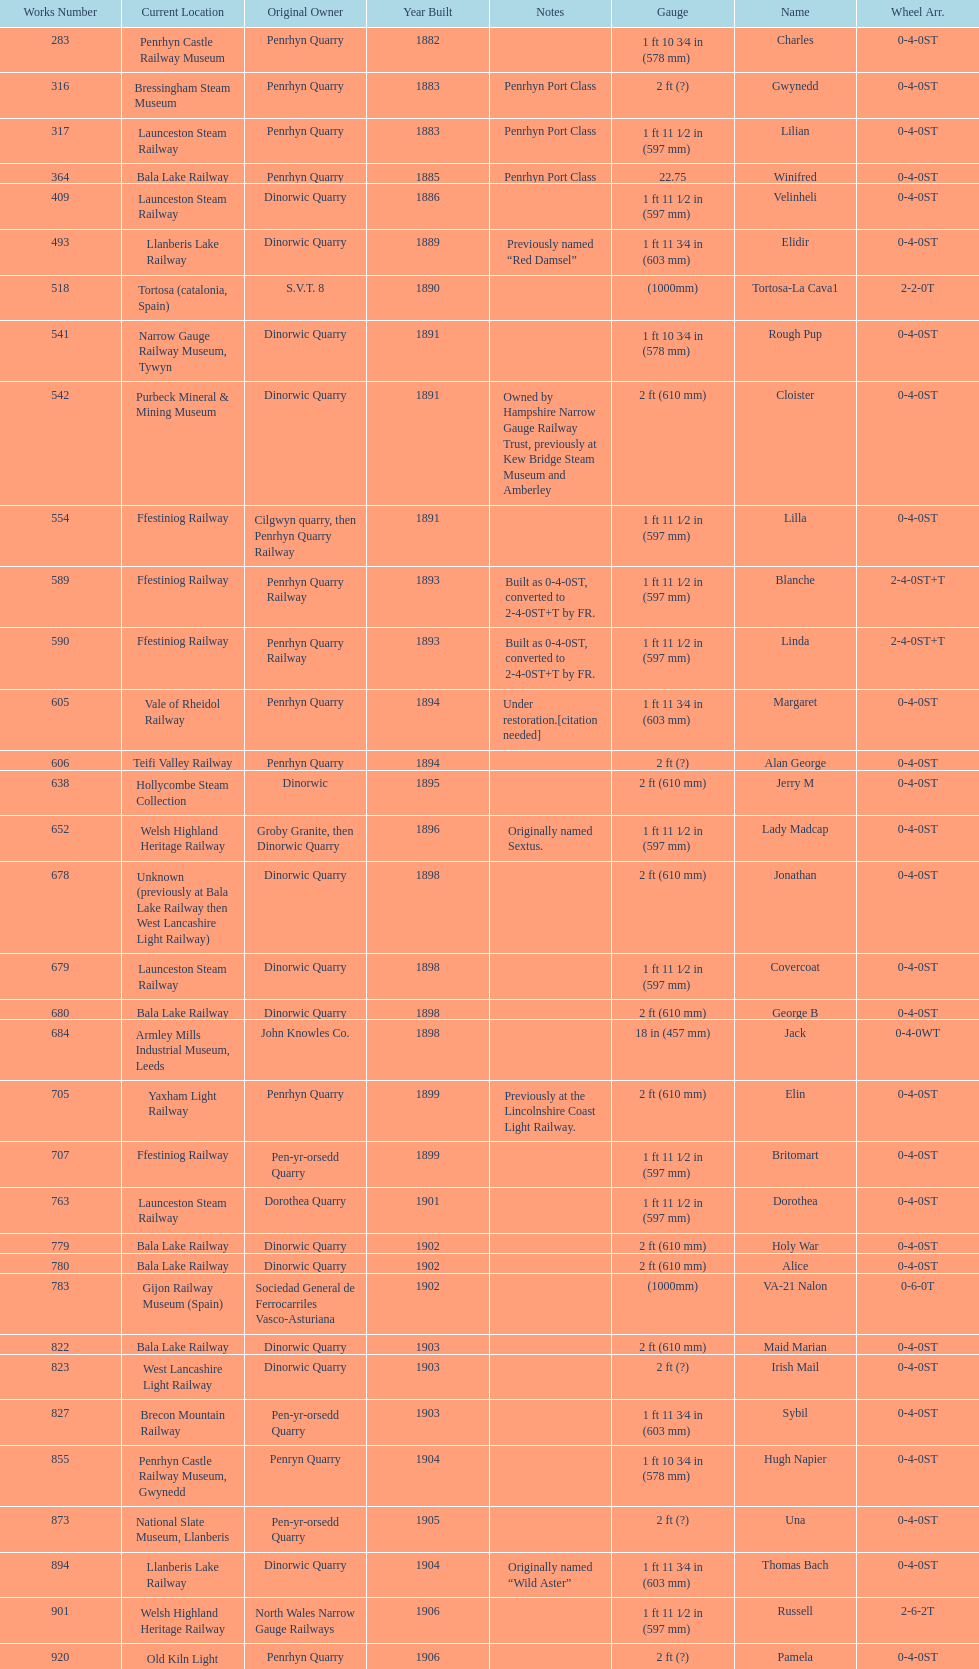Parse the table in full. {'header': ['Works Number', 'Current Location', 'Original Owner', 'Year Built', 'Notes', 'Gauge', 'Name', 'Wheel Arr.'], 'rows': [['283', 'Penrhyn Castle Railway Museum', 'Penrhyn Quarry', '1882', '', '1\xa0ft 10\xa03⁄4\xa0in (578\xa0mm)', 'Charles', '0-4-0ST'], ['316', 'Bressingham Steam Museum', 'Penrhyn Quarry', '1883', 'Penrhyn Port Class', '2\xa0ft (?)', 'Gwynedd', '0-4-0ST'], ['317', 'Launceston Steam Railway', 'Penrhyn Quarry', '1883', 'Penrhyn Port Class', '1\xa0ft 11\xa01⁄2\xa0in (597\xa0mm)', 'Lilian', '0-4-0ST'], ['364', 'Bala Lake Railway', 'Penrhyn Quarry', '1885', 'Penrhyn Port Class', '22.75', 'Winifred', '0-4-0ST'], ['409', 'Launceston Steam Railway', 'Dinorwic Quarry', '1886', '', '1\xa0ft 11\xa01⁄2\xa0in (597\xa0mm)', 'Velinheli', '0-4-0ST'], ['493', 'Llanberis Lake Railway', 'Dinorwic Quarry', '1889', 'Previously named “Red Damsel”', '1\xa0ft 11\xa03⁄4\xa0in (603\xa0mm)', 'Elidir', '0-4-0ST'], ['518', 'Tortosa (catalonia, Spain)', 'S.V.T. 8', '1890', '', '(1000mm)', 'Tortosa-La Cava1', '2-2-0T'], ['541', 'Narrow Gauge Railway Museum, Tywyn', 'Dinorwic Quarry', '1891', '', '1\xa0ft 10\xa03⁄4\xa0in (578\xa0mm)', 'Rough Pup', '0-4-0ST'], ['542', 'Purbeck Mineral & Mining Museum', 'Dinorwic Quarry', '1891', 'Owned by Hampshire Narrow Gauge Railway Trust, previously at Kew Bridge Steam Museum and Amberley', '2\xa0ft (610\xa0mm)', 'Cloister', '0-4-0ST'], ['554', 'Ffestiniog Railway', 'Cilgwyn quarry, then Penrhyn Quarry Railway', '1891', '', '1\xa0ft 11\xa01⁄2\xa0in (597\xa0mm)', 'Lilla', '0-4-0ST'], ['589', 'Ffestiniog Railway', 'Penrhyn Quarry Railway', '1893', 'Built as 0-4-0ST, converted to 2-4-0ST+T by FR.', '1\xa0ft 11\xa01⁄2\xa0in (597\xa0mm)', 'Blanche', '2-4-0ST+T'], ['590', 'Ffestiniog Railway', 'Penrhyn Quarry Railway', '1893', 'Built as 0-4-0ST, converted to 2-4-0ST+T by FR.', '1\xa0ft 11\xa01⁄2\xa0in (597\xa0mm)', 'Linda', '2-4-0ST+T'], ['605', 'Vale of Rheidol Railway', 'Penrhyn Quarry', '1894', 'Under restoration.[citation needed]', '1\xa0ft 11\xa03⁄4\xa0in (603\xa0mm)', 'Margaret', '0-4-0ST'], ['606', 'Teifi Valley Railway', 'Penrhyn Quarry', '1894', '', '2\xa0ft (?)', 'Alan George', '0-4-0ST'], ['638', 'Hollycombe Steam Collection', 'Dinorwic', '1895', '', '2\xa0ft (610\xa0mm)', 'Jerry M', '0-4-0ST'], ['652', 'Welsh Highland Heritage Railway', 'Groby Granite, then Dinorwic Quarry', '1896', 'Originally named Sextus.', '1\xa0ft 11\xa01⁄2\xa0in (597\xa0mm)', 'Lady Madcap', '0-4-0ST'], ['678', 'Unknown (previously at Bala Lake Railway then West Lancashire Light Railway)', 'Dinorwic Quarry', '1898', '', '2\xa0ft (610\xa0mm)', 'Jonathan', '0-4-0ST'], ['679', 'Launceston Steam Railway', 'Dinorwic Quarry', '1898', '', '1\xa0ft 11\xa01⁄2\xa0in (597\xa0mm)', 'Covercoat', '0-4-0ST'], ['680', 'Bala Lake Railway', 'Dinorwic Quarry', '1898', '', '2\xa0ft (610\xa0mm)', 'George B', '0-4-0ST'], ['684', 'Armley Mills Industrial Museum, Leeds', 'John Knowles Co.', '1898', '', '18\xa0in (457\xa0mm)', 'Jack', '0-4-0WT'], ['705', 'Yaxham Light Railway', 'Penrhyn Quarry', '1899', 'Previously at the Lincolnshire Coast Light Railway.', '2\xa0ft (610\xa0mm)', 'Elin', '0-4-0ST'], ['707', 'Ffestiniog Railway', 'Pen-yr-orsedd Quarry', '1899', '', '1\xa0ft 11\xa01⁄2\xa0in (597\xa0mm)', 'Britomart', '0-4-0ST'], ['763', 'Launceston Steam Railway', 'Dorothea Quarry', '1901', '', '1\xa0ft 11\xa01⁄2\xa0in (597\xa0mm)', 'Dorothea', '0-4-0ST'], ['779', 'Bala Lake Railway', 'Dinorwic Quarry', '1902', '', '2\xa0ft (610\xa0mm)', 'Holy War', '0-4-0ST'], ['780', 'Bala Lake Railway', 'Dinorwic Quarry', '1902', '', '2\xa0ft (610\xa0mm)', 'Alice', '0-4-0ST'], ['783', 'Gijon Railway Museum (Spain)', 'Sociedad General de Ferrocarriles Vasco-Asturiana', '1902', '', '(1000mm)', 'VA-21 Nalon', '0-6-0T'], ['822', 'Bala Lake Railway', 'Dinorwic Quarry', '1903', '', '2\xa0ft (610\xa0mm)', 'Maid Marian', '0-4-0ST'], ['823', 'West Lancashire Light Railway', 'Dinorwic Quarry', '1903', '', '2\xa0ft (?)', 'Irish Mail', '0-4-0ST'], ['827', 'Brecon Mountain Railway', 'Pen-yr-orsedd Quarry', '1903', '', '1\xa0ft 11\xa03⁄4\xa0in (603\xa0mm)', 'Sybil', '0-4-0ST'], ['855', 'Penrhyn Castle Railway Museum, Gwynedd', 'Penryn Quarry', '1904', '', '1\xa0ft 10\xa03⁄4\xa0in (578\xa0mm)', 'Hugh Napier', '0-4-0ST'], ['873', 'National Slate Museum, Llanberis', 'Pen-yr-orsedd Quarry', '1905', '', '2\xa0ft (?)', 'Una', '0-4-0ST'], ['894', 'Llanberis Lake Railway', 'Dinorwic Quarry', '1904', 'Originally named “Wild Aster”', '1\xa0ft 11\xa03⁄4\xa0in (603\xa0mm)', 'Thomas Bach', '0-4-0ST'], ['901', 'Welsh Highland Heritage Railway', 'North Wales Narrow Gauge Railways', '1906', '', '1\xa0ft 11\xa01⁄2\xa0in (597\xa0mm)', 'Russell', '2-6-2T'], ['920', 'Old Kiln Light Railway', 'Penrhyn Quarry', '1906', '', '2\xa0ft (?)', 'Pamela', '0-4-0ST'], ['994', 'Bressingham Steam Museum', 'Penrhyn Quarry', '1909', 'previously George Sholto', '2\xa0ft (?)', 'Bill Harvey', '0-4-0ST'], ['1312', 'Pampas Safari, Gravataí, RS, Brazil', 'British War Department\\nEFOP #203', '1918', '[citation needed]', '1\xa0ft\xa011\xa01⁄2\xa0in (597\xa0mm)', '---', '4-6-0T'], ['1313', 'Usina Laginha, União dos Palmares, AL, Brazil', 'British War Department\\nUsina Leão Utinga #1\\nUsina Laginha #1', '1918\\nor\\n1921?', '[citation needed]', '3\xa0ft\xa03\xa03⁄8\xa0in (1,000\xa0mm)', '---', '0-6-2T'], ['1404', 'Richard Farmer current owner, Northridge, California, USA', 'John Knowles Co.', '1920', '', '18\xa0in (457\xa0mm)', 'Gwen', '0-4-0WT'], ['1429', 'Bredgar and Wormshill Light Railway', 'Dinorwic', '1922', '', '2\xa0ft (610\xa0mm)', 'Lady Joan', '0-4-0ST'], ['1430', 'Llanberis Lake Railway', 'Dinorwic Quarry', '1922', '', '1\xa0ft 11\xa03⁄4\xa0in (603\xa0mm)', 'Dolbadarn', '0-4-0ST'], ['1859', 'South Tynedale Railway', 'Umtwalumi Valley Estate, Natal', '1937', '', '2\xa0ft (?)', '16 Carlisle', '0-4-2T'], ['2075', 'North Gloucestershire Railway', 'Chaka’s Kraal Sugar Estates, Natal', '1940', '', '2\xa0ft (?)', 'Chaka’s Kraal No. 6', '0-4-2T'], ['3815', 'Welshpool and Llanfair Light Railway', 'Sierra Leone Government Railway', '1954', '', '2\xa0ft 6\xa0in (762\xa0mm)', '14', '2-6-2T'], ['3902', 'Statfold Barn Railway', 'Trangkil Sugar Mill, Indonesia', '1971', 'Converted from 750\xa0mm (2\xa0ft\xa05\xa01⁄2\xa0in) gauge. Last steam locomotive to be built by Hunslet, and the last industrial steam locomotive built in Britain.', '2\xa0ft (610\xa0mm)', 'Trangkil No.4', '0-4-2ST']]} Who owned the last locomotive to be built? Trangkil Sugar Mill, Indonesia. 